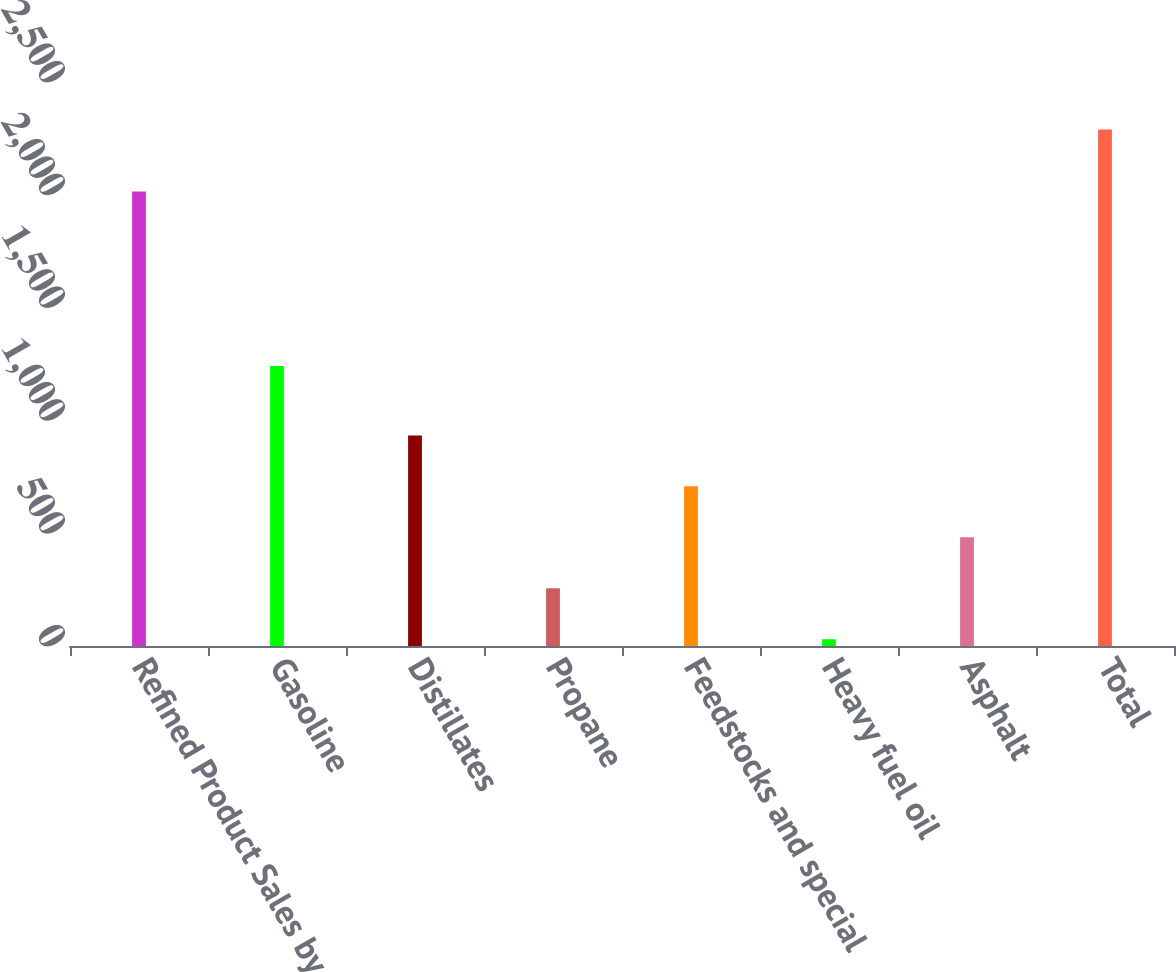Convert chart to OTSL. <chart><loc_0><loc_0><loc_500><loc_500><bar_chart><fcel>Refined Product Sales by<fcel>Gasoline<fcel>Distillates<fcel>Propane<fcel>Feedstocks and special<fcel>Heavy fuel oil<fcel>Asphalt<fcel>Total<nl><fcel>2015<fcel>1241<fcel>933.6<fcel>255.9<fcel>707.7<fcel>30<fcel>481.8<fcel>2289<nl></chart> 